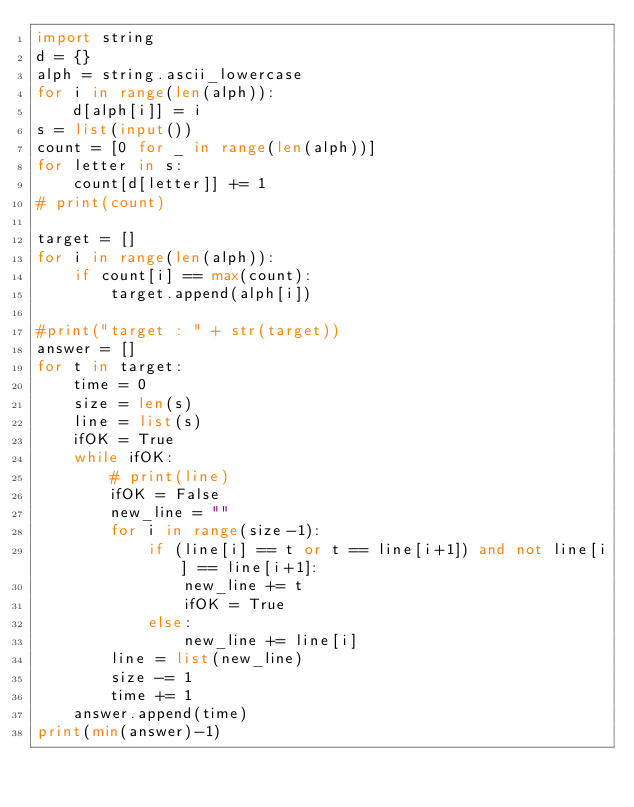Convert code to text. <code><loc_0><loc_0><loc_500><loc_500><_Python_>import string
d = {}
alph = string.ascii_lowercase
for i in range(len(alph)):
    d[alph[i]] = i
s = list(input())
count = [0 for _ in range(len(alph))]
for letter in s:
    count[d[letter]] += 1
# print(count)

target = []
for i in range(len(alph)):
    if count[i] == max(count):
        target.append(alph[i])

#print("target : " + str(target))
answer = []
for t in target:
    time = 0
    size = len(s)
    line = list(s)
    ifOK = True
    while ifOK:
        # print(line)
        ifOK = False
        new_line = ""
        for i in range(size-1):
            if (line[i] == t or t == line[i+1]) and not line[i] == line[i+1]:
                new_line += t
                ifOK = True
            else:
                new_line += line[i]
        line = list(new_line)
        size -= 1
        time += 1
    answer.append(time)
print(min(answer)-1)
</code> 